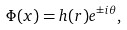<formula> <loc_0><loc_0><loc_500><loc_500>\Phi ( { x } ) = h ( r ) e ^ { \pm i \theta } ,</formula> 